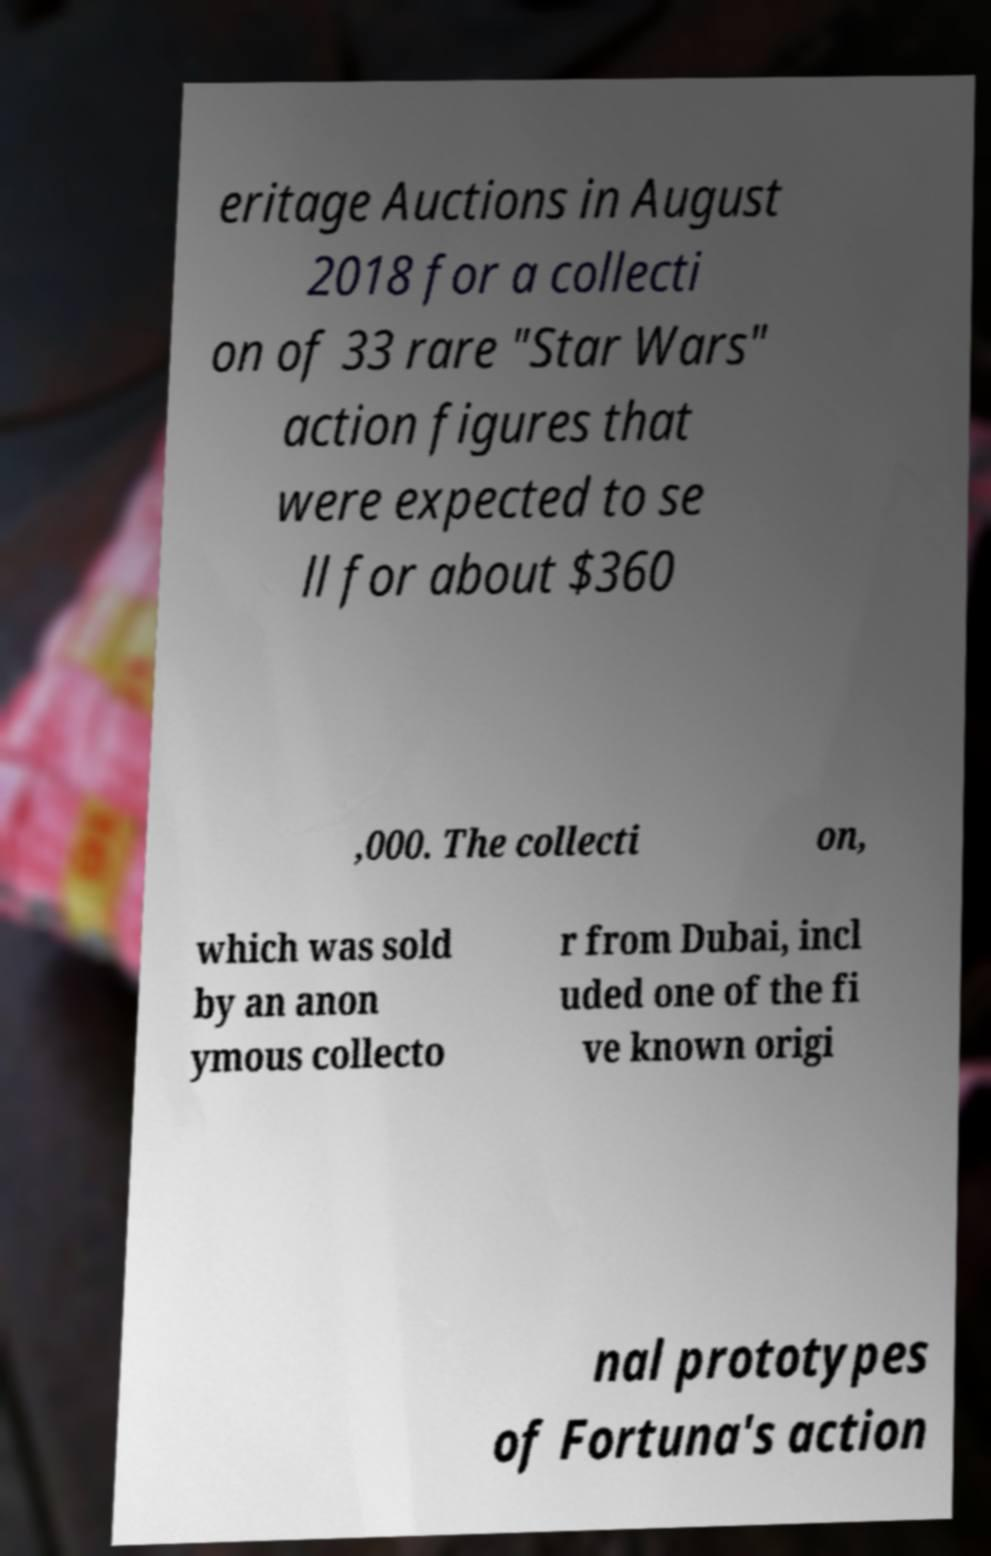Can you accurately transcribe the text from the provided image for me? eritage Auctions in August 2018 for a collecti on of 33 rare "Star Wars" action figures that were expected to se ll for about $360 ,000. The collecti on, which was sold by an anon ymous collecto r from Dubai, incl uded one of the fi ve known origi nal prototypes of Fortuna's action 